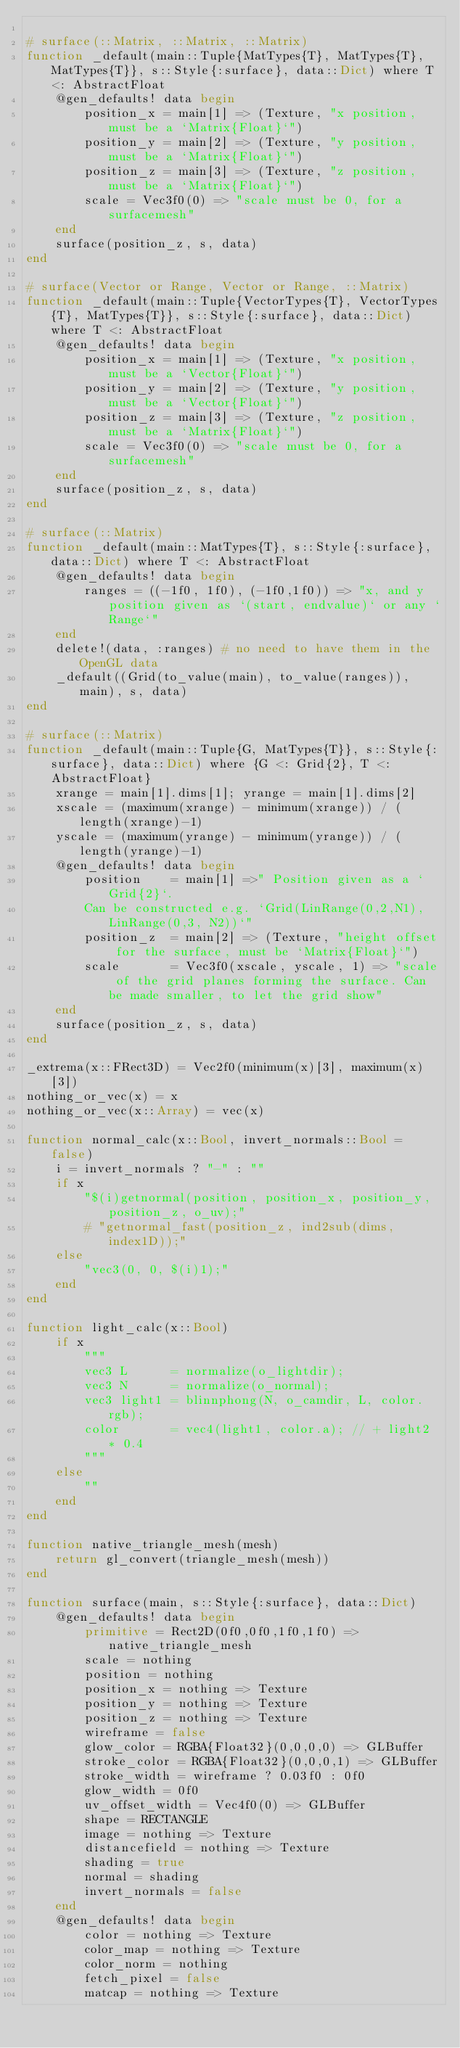Convert code to text. <code><loc_0><loc_0><loc_500><loc_500><_Julia_>
# surface(::Matrix, ::Matrix, ::Matrix)
function _default(main::Tuple{MatTypes{T}, MatTypes{T}, MatTypes{T}}, s::Style{:surface}, data::Dict) where T <: AbstractFloat
    @gen_defaults! data begin
        position_x = main[1] => (Texture, "x position, must be a `Matrix{Float}`")
        position_y = main[2] => (Texture, "y position, must be a `Matrix{Float}`")
        position_z = main[3] => (Texture, "z position, must be a `Matrix{Float}`")
        scale = Vec3f0(0) => "scale must be 0, for a surfacemesh"
    end
    surface(position_z, s, data)
end

# surface(Vector or Range, Vector or Range, ::Matrix)
function _default(main::Tuple{VectorTypes{T}, VectorTypes{T}, MatTypes{T}}, s::Style{:surface}, data::Dict) where T <: AbstractFloat
    @gen_defaults! data begin
        position_x = main[1] => (Texture, "x position, must be a `Vector{Float}`")
        position_y = main[2] => (Texture, "y position, must be a `Vector{Float}`")
        position_z = main[3] => (Texture, "z position, must be a `Matrix{Float}`")
        scale = Vec3f0(0) => "scale must be 0, for a surfacemesh"
    end
    surface(position_z, s, data)
end

# surface(::Matrix)
function _default(main::MatTypes{T}, s::Style{:surface}, data::Dict) where T <: AbstractFloat
    @gen_defaults! data begin
        ranges = ((-1f0, 1f0), (-1f0,1f0)) => "x, and y position given as `(start, endvalue)` or any `Range`"
    end
    delete!(data, :ranges) # no need to have them in the OpenGL data
    _default((Grid(to_value(main), to_value(ranges)), main), s, data)
end

# surface(::Matrix)
function _default(main::Tuple{G, MatTypes{T}}, s::Style{:surface}, data::Dict) where {G <: Grid{2}, T <: AbstractFloat}
    xrange = main[1].dims[1]; yrange = main[1].dims[2]
    xscale = (maximum(xrange) - minimum(xrange)) / (length(xrange)-1)
    yscale = (maximum(yrange) - minimum(yrange)) / (length(yrange)-1)
    @gen_defaults! data begin
        position    = main[1] =>" Position given as a `Grid{2}`.
        Can be constructed e.g. `Grid(LinRange(0,2,N1), LinRange(0,3, N2))`"
        position_z  = main[2] => (Texture, "height offset for the surface, must be `Matrix{Float}`")
        scale       = Vec3f0(xscale, yscale, 1) => "scale of the grid planes forming the surface. Can be made smaller, to let the grid show"
    end
    surface(position_z, s, data)
end

_extrema(x::FRect3D) = Vec2f0(minimum(x)[3], maximum(x)[3])
nothing_or_vec(x) = x
nothing_or_vec(x::Array) = vec(x)

function normal_calc(x::Bool, invert_normals::Bool = false)
    i = invert_normals ? "-" : ""
    if x
        "$(i)getnormal(position, position_x, position_y, position_z, o_uv);"
        # "getnormal_fast(position_z, ind2sub(dims, index1D));"
    else
        "vec3(0, 0, $(i)1);"
    end
end

function light_calc(x::Bool)
    if x
        """
        vec3 L      = normalize(o_lightdir);
        vec3 N      = normalize(o_normal);
        vec3 light1 = blinnphong(N, o_camdir, L, color.rgb);
        color       = vec4(light1, color.a); // + light2 * 0.4
        """
    else
        ""
    end
end

function native_triangle_mesh(mesh)
    return gl_convert(triangle_mesh(mesh))
end

function surface(main, s::Style{:surface}, data::Dict)
    @gen_defaults! data begin
        primitive = Rect2D(0f0,0f0,1f0,1f0) => native_triangle_mesh
        scale = nothing
        position = nothing
        position_x = nothing => Texture
        position_y = nothing => Texture
        position_z = nothing => Texture
        wireframe = false
        glow_color = RGBA{Float32}(0,0,0,0) => GLBuffer
        stroke_color = RGBA{Float32}(0,0,0,1) => GLBuffer
        stroke_width = wireframe ? 0.03f0 : 0f0
        glow_width = 0f0
        uv_offset_width = Vec4f0(0) => GLBuffer
        shape = RECTANGLE
        image = nothing => Texture
        distancefield = nothing => Texture
        shading = true
        normal = shading
        invert_normals = false
    end
    @gen_defaults! data begin
        color = nothing => Texture
        color_map = nothing => Texture
        color_norm = nothing
        fetch_pixel = false
        matcap = nothing => Texture</code> 